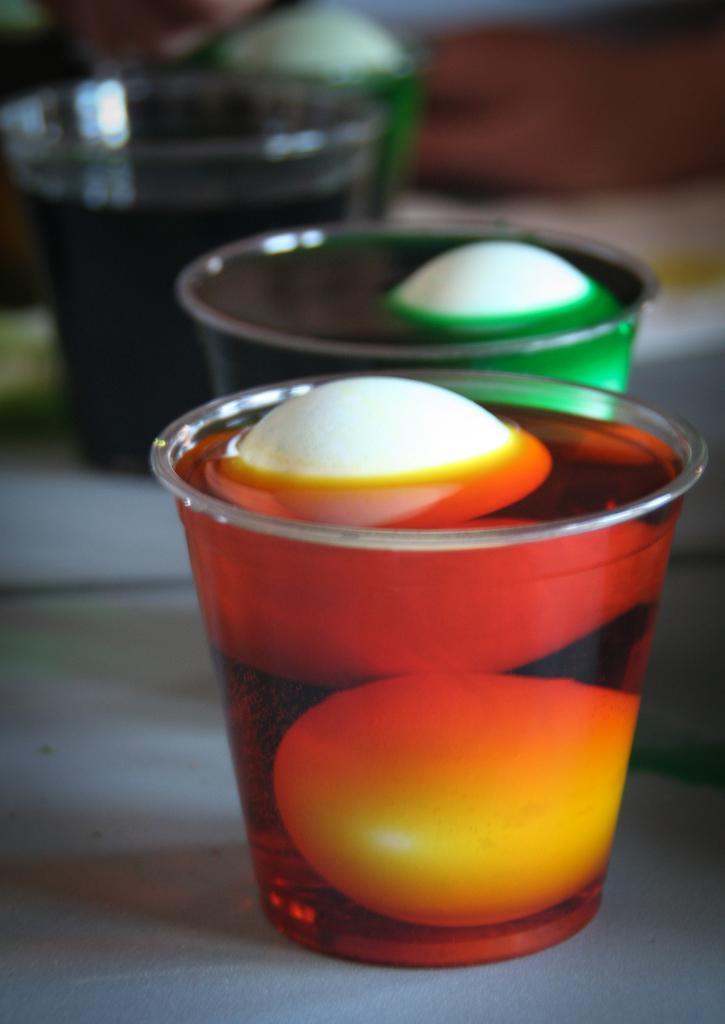Please provide a concise description of this image. In this picture we can see glasses, there is some drink present in these glasses, we can see a blurry background. 